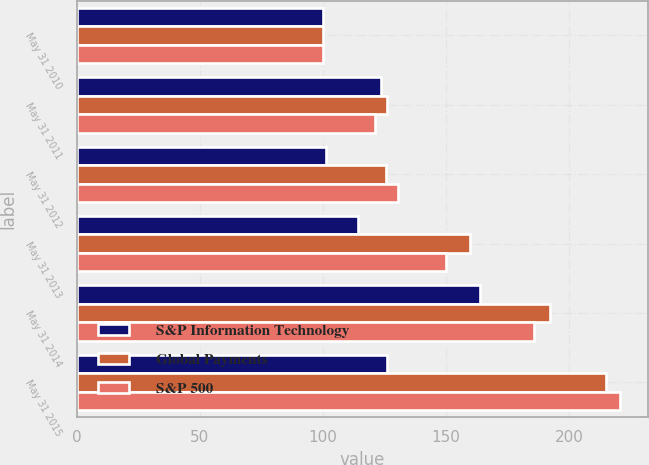<chart> <loc_0><loc_0><loc_500><loc_500><stacked_bar_chart><ecel><fcel>May 31 2010<fcel>May 31 2011<fcel>May 31 2012<fcel>May 31 2013<fcel>May 31 2014<fcel>May 31 2015<nl><fcel>S&P Information Technology<fcel>100<fcel>123.38<fcel>101.05<fcel>114.29<fcel>163.59<fcel>125.95<nl><fcel>Global Payments<fcel>100<fcel>125.95<fcel>125.43<fcel>159.64<fcel>192.28<fcel>214.99<nl><fcel>S&P 500<fcel>100<fcel>121.13<fcel>130.3<fcel>150<fcel>185.84<fcel>220.8<nl></chart> 